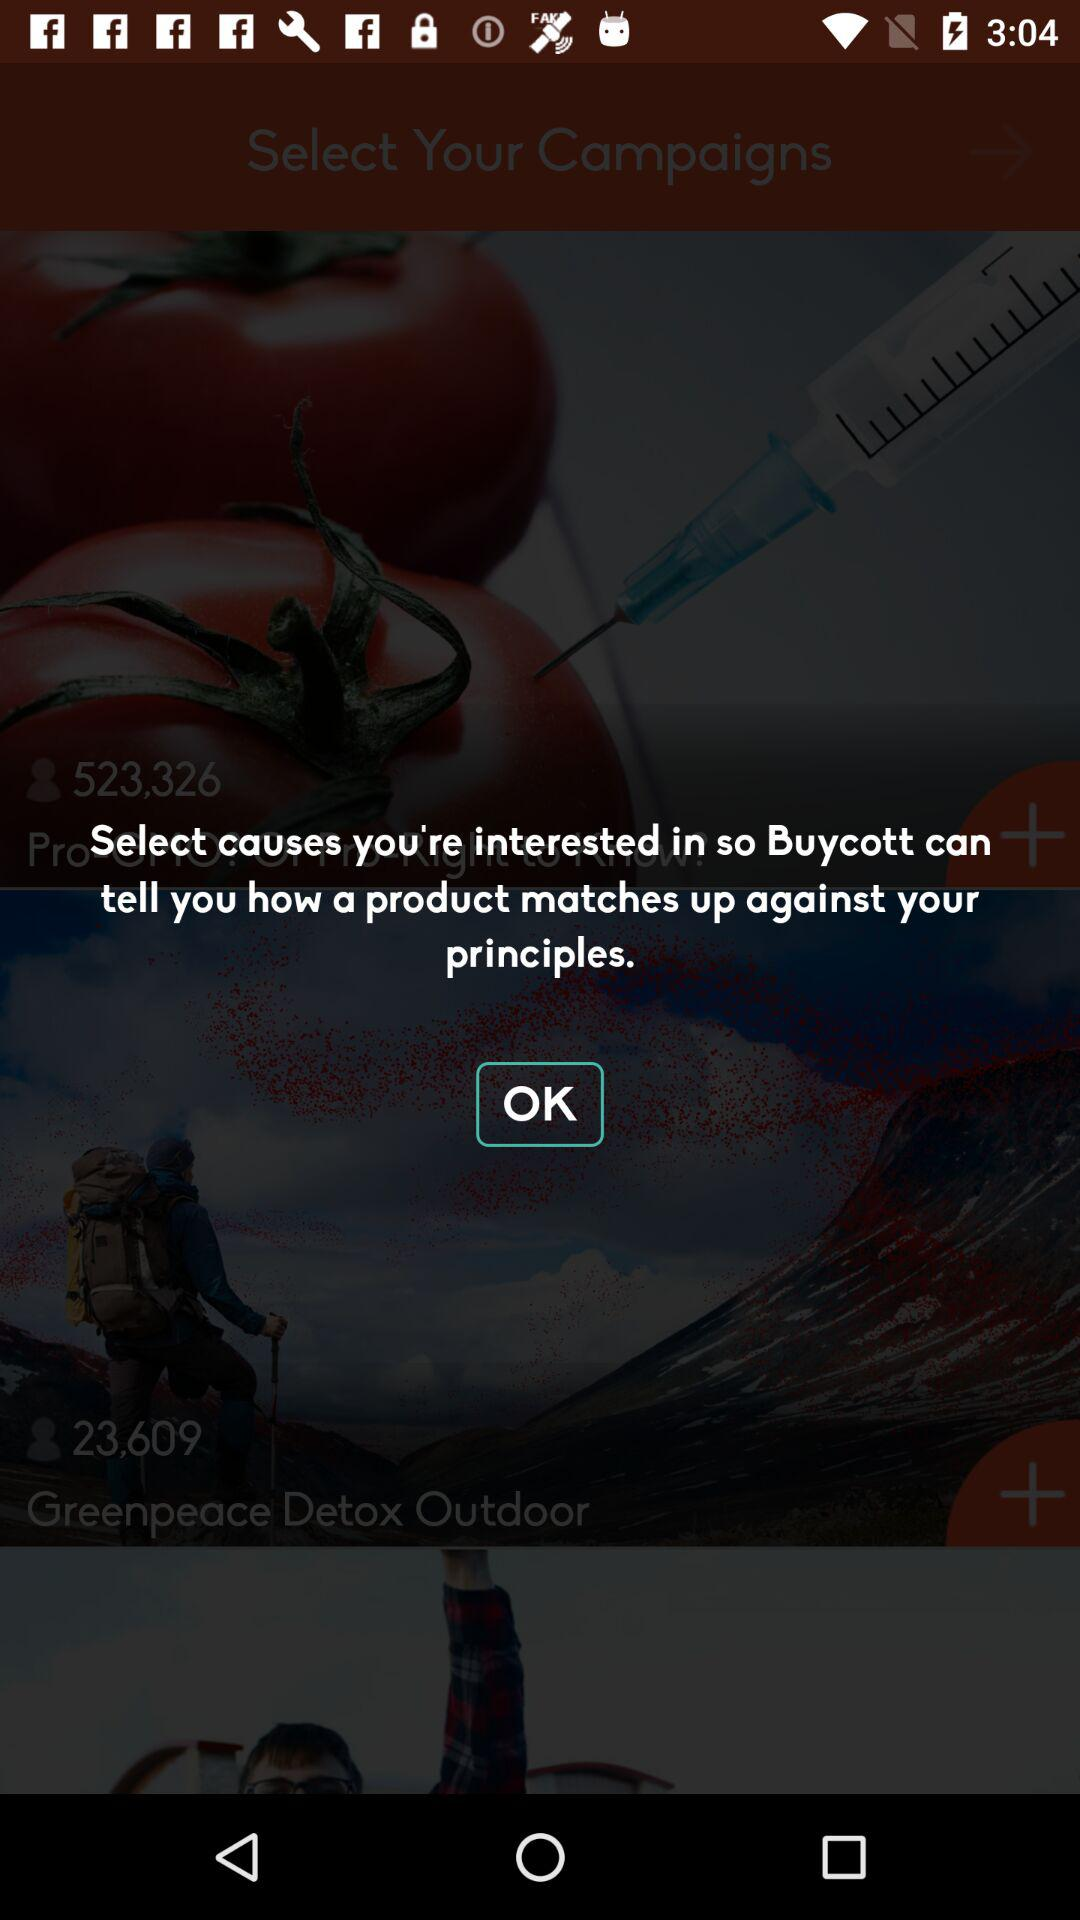How many campaigns are there in total?
Answer the question using a single word or phrase. 2 